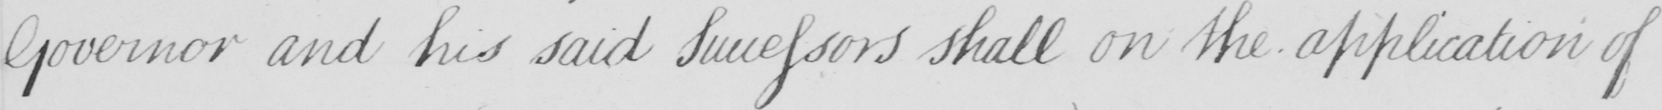What is written in this line of handwriting? Governor and his said Successors shall on the application of 